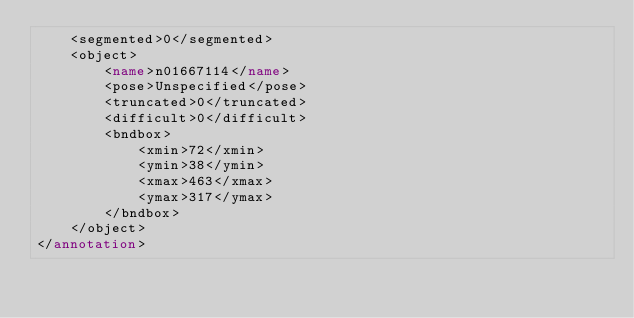<code> <loc_0><loc_0><loc_500><loc_500><_XML_>	<segmented>0</segmented>
	<object>
		<name>n01667114</name>
		<pose>Unspecified</pose>
		<truncated>0</truncated>
		<difficult>0</difficult>
		<bndbox>
			<xmin>72</xmin>
			<ymin>38</ymin>
			<xmax>463</xmax>
			<ymax>317</ymax>
		</bndbox>
	</object>
</annotation></code> 